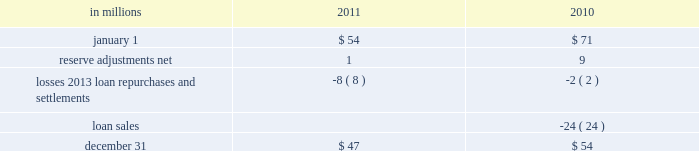Recourse and repurchase obligations as discussed in note 3 loans sale and servicing activities and variable interest entities , pnc has sold commercial mortgage and residential mortgage loans directly or indirectly in securitizations and whole-loan sale transactions with continuing involvement .
One form of continuing involvement includes certain recourse and loan repurchase obligations associated with the transferred assets in these transactions .
Commercial mortgage loan recourse obligations we originate , close and service certain multi-family commercial mortgage loans which are sold to fnma under fnma 2019s dus program .
We participated in a similar program with the fhlmc .
Under these programs , we generally assume up to a one-third pari passu risk of loss on unpaid principal balances through a loss share arrangement .
At december 31 , 2011 and december 31 , 2010 , the unpaid principal balance outstanding of loans sold as a participant in these programs was $ 13.0 billion and $ 13.2 billion , respectively .
The potential maximum exposure under the loss share arrangements was $ 4.0 billion at both december 31 , 2011 and december 31 , 2010 .
We maintain a reserve for estimated losses based upon our exposure .
The reserve for losses under these programs totaled $ 47 million and $ 54 million as of december 31 , 2011 and december 31 , 2010 , respectively , and is included in other liabilities on our consolidated balance sheet .
If payment is required under these programs , we would not have a contractual interest in the collateral underlying the mortgage loans on which losses occurred , although the value of the collateral is taken into account in determining our share of such losses .
Our exposure and activity associated with these recourse obligations are reported in the corporate & institutional banking segment .
Analysis of commercial mortgage recourse obligations .
Residential mortgage loan and home equity repurchase obligations while residential mortgage loans are sold on a non-recourse basis , we assume certain loan repurchase obligations associated with mortgage loans we have sold to investors .
These loan repurchase obligations primarily relate to situations where pnc is alleged to have breached certain origination covenants and representations and warranties made to purchasers of the loans in the respective purchase and sale agreements .
Residential mortgage loans covered by these loan repurchase obligations include first and second-lien mortgage loans we have sold through agency securitizations , non-agency securitizations , and whole-loan sale transactions .
As discussed in note 3 in this report , agency securitizations consist of mortgage loans sale transactions with fnma , fhlmc , and gnma , while non-agency securitizations and whole-loan sale transactions consist of mortgage loans sale transactions with private investors .
Our historical exposure and activity associated with agency securitization repurchase obligations has primarily been related to transactions with fnma and fhlmc , as indemnification and repurchase losses associated with fha and va-insured and uninsured loans pooled in gnma securitizations historically have been minimal .
Repurchase obligation activity associated with residential mortgages is reported in the residential mortgage banking segment .
Pnc 2019s repurchase obligations also include certain brokered home equity loans/lines that were sold to a limited number of private investors in the financial services industry by national city prior to our acquisition .
Pnc is no longer engaged in the brokered home equity lending business , and our exposure under these loan repurchase obligations is limited to repurchases of whole-loans sold in these transactions .
Repurchase activity associated with brokered home equity loans/lines is reported in the non-strategic assets portfolio segment .
Loan covenants and representations and warranties are established through loan sale agreements with various investors to provide assurance that pnc has sold loans to investors of sufficient investment quality .
Key aspects of such covenants and representations and warranties include the loan 2019s compliance with any applicable loan criteria established by the investor , including underwriting standards , delivery of all required loan documents to the investor or its designated party , sufficient collateral valuation , and the validity of the lien securing the loan .
As a result of alleged breaches of these contractual obligations , investors may request pnc to indemnify them against losses on certain loans or to repurchase loans .
These investor indemnification or repurchase claims are typically settled on an individual loan basis through make- whole payments or loan repurchases ; however , on occasion we may negotiate pooled settlements with investors .
Indemnifications for loss or loan repurchases typically occur when , after review of the claim , we agree insufficient evidence exists to dispute the investor 2019s claim that a breach of a loan covenant and representation and warranty has occurred , such breach has not been cured , and the effect of such breach is deemed to have had a material and adverse effect on the value of the transferred loan .
Depending on the sale agreement and upon proper notice from the investor , we typically respond to such indemnification and repurchase requests within 60 days , although final resolution of the claim may take a longer period of time .
With the exception of the sales the pnc financial services group , inc .
2013 form 10-k 199 .
For commercial mortgage recourse obligations , what was average reserve adjustments net for 2010 and 2011 , in millions? 
Computations: table_average(reserve adjustments net, none)
Answer: 5.0. 